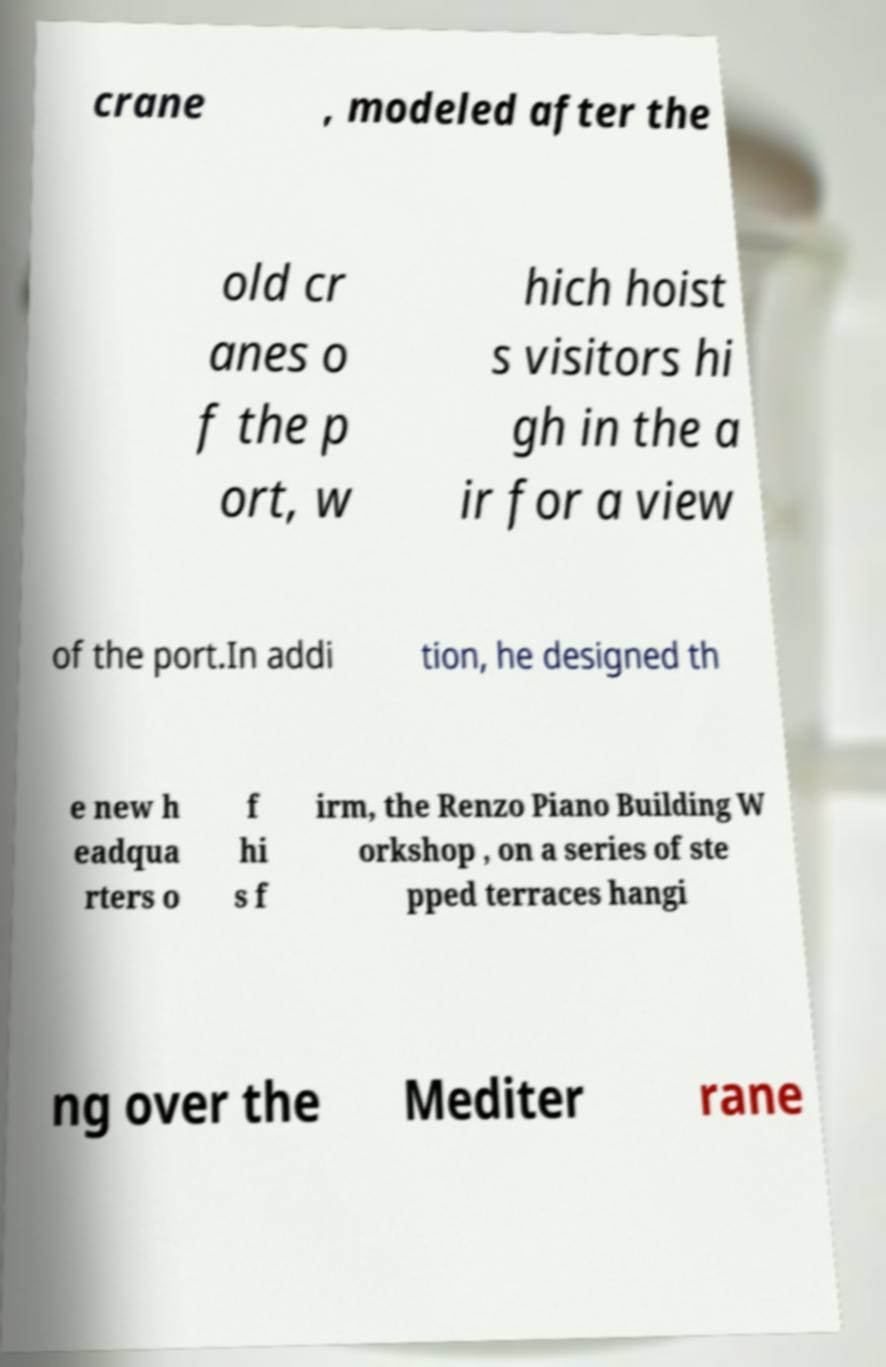What messages or text are displayed in this image? I need them in a readable, typed format. crane , modeled after the old cr anes o f the p ort, w hich hoist s visitors hi gh in the a ir for a view of the port.In addi tion, he designed th e new h eadqua rters o f hi s f irm, the Renzo Piano Building W orkshop , on a series of ste pped terraces hangi ng over the Mediter rane 